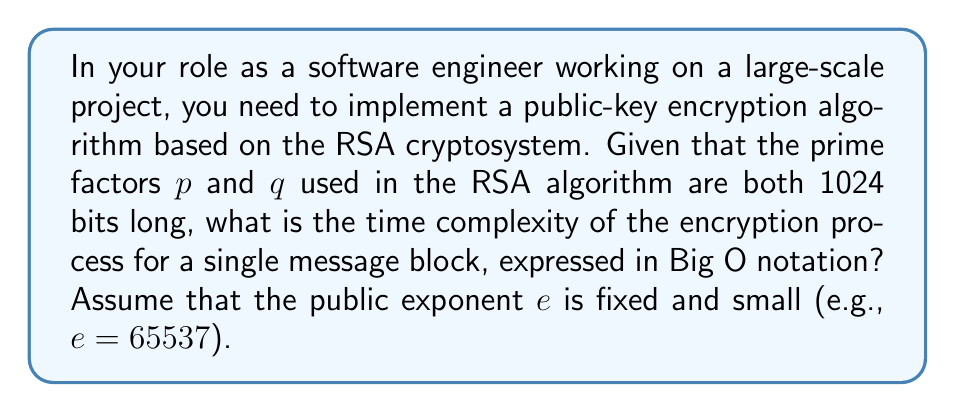Provide a solution to this math problem. To calculate the time complexity of the RSA encryption process, we need to consider the following steps:

1. The RSA encryption formula is $c = m^e \mod n$, where:
   - $c$ is the ciphertext
   - $m$ is the message (plaintext)
   - $e$ is the public exponent
   - $n$ is the modulus (product of $p$ and $q$)

2. Given that $p$ and $q$ are both 1024 bits long, the modulus $n = p \times q$ will be approximately 2048 bits long.

3. The main operation in RSA encryption is modular exponentiation $(m^e \mod n)$.

4. For modular exponentiation, we typically use the square-and-multiply algorithm, which has a time complexity of $O(\log e)$ multiplications.

5. Each multiplication involves operands of size 2048 bits (the size of $n$).

6. The time complexity of multiplying two $k$-bit numbers using a standard algorithm is $O(k^2)$.

7. Therefore, each multiplication in the modular exponentiation process has a time complexity of $O(2048^2) = O(4194304)$.

8. Since $e$ is fixed and small (e.g., 65537), $\log e$ is essentially constant.

9. Combining steps 4, 7, and 8, the overall time complexity is:
   $O(\log e) \times O(2048^2) = O(2048^2) = O(k^2)$, where $k$ is the bit length of the modulus.

Thus, the time complexity of the RSA encryption process for a single message block, with respect to the bit length of the modulus, is $O(k^2)$.
Answer: $O(k^2)$, where $k$ is the bit length of the modulus 